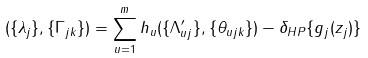<formula> <loc_0><loc_0><loc_500><loc_500>( \{ \lambda _ { j } \} , \{ \Gamma _ { j k } \} ) = \sum _ { u = 1 } ^ { m } h _ { u } ( \{ \Lambda ^ { \prime } _ { u j } \} , \{ \theta _ { u j k } \} ) - \delta _ { H P } \{ g _ { j } ( z _ { j } ) \}</formula> 